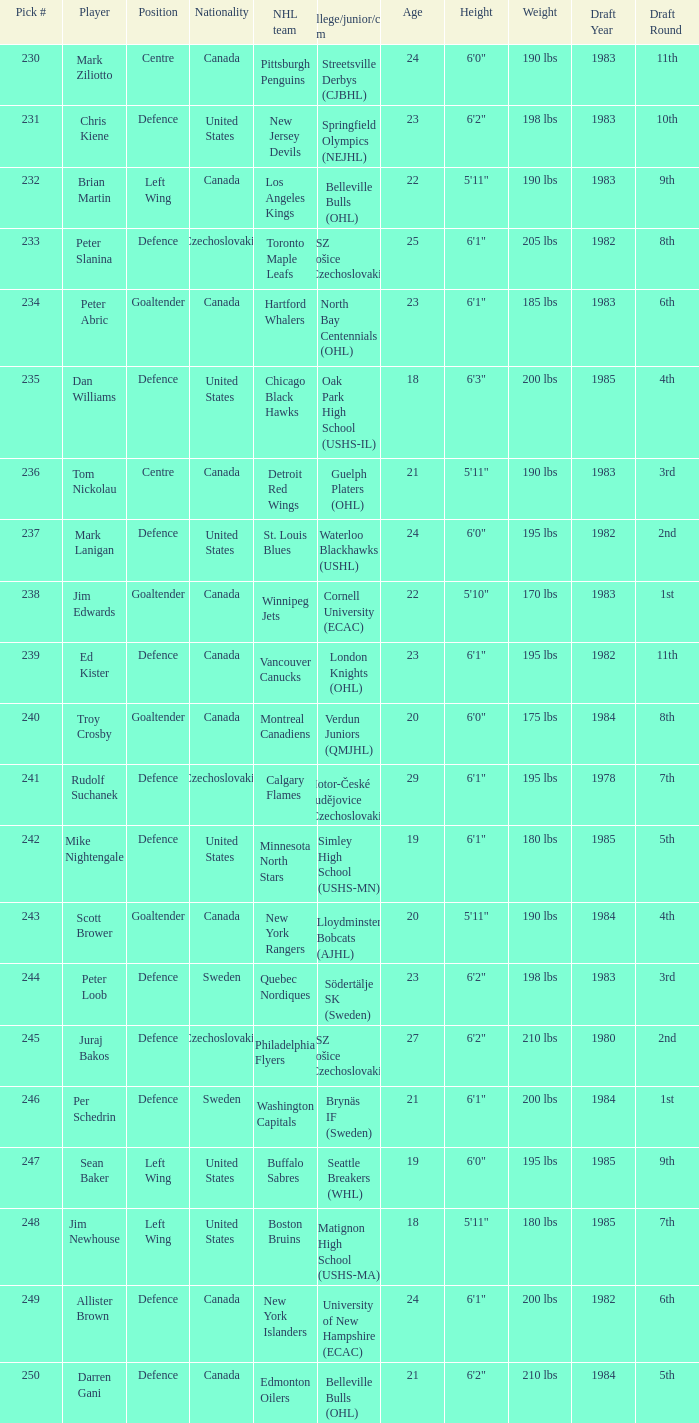What selection was the springfield olympics (nejhl)? 231.0. 